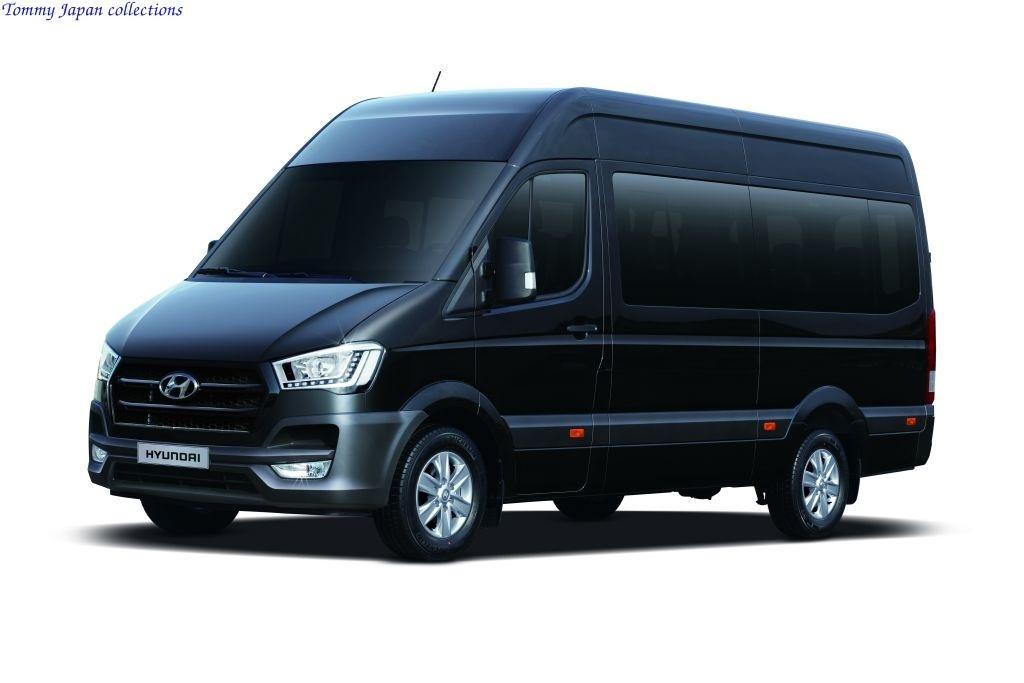Can you describe this image briefly? In this image I can see a vehicle which is black in color and I can see the white background. 